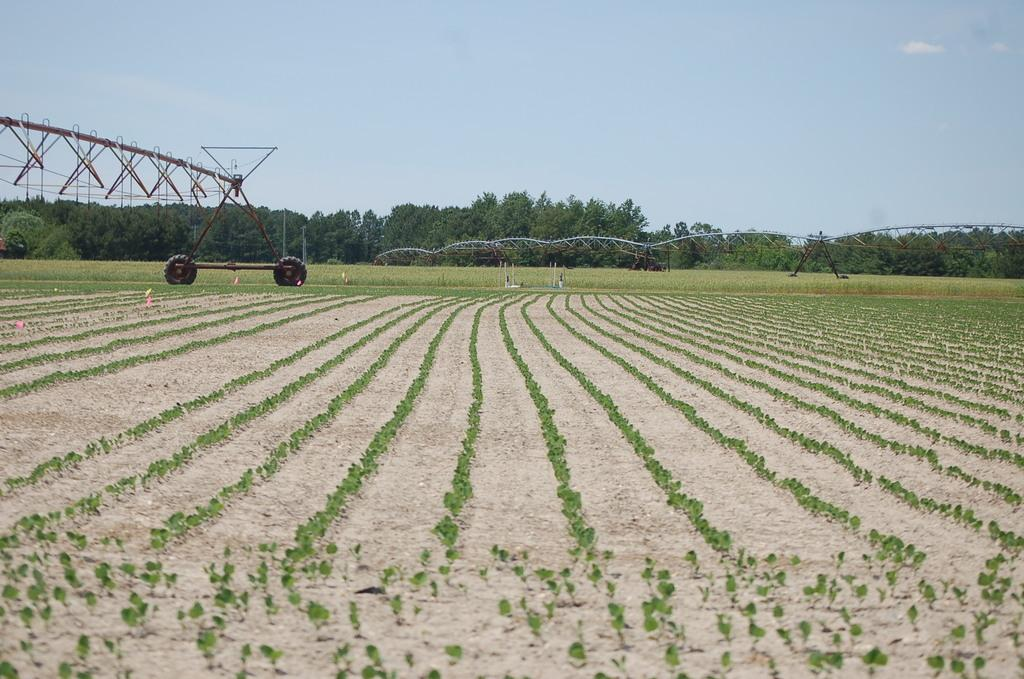What type of vegetation can be seen in the image? There are crops in the image. What structures are present among the crops? There are metal rod structures with tires in the image. What can be seen in the background of the image? There are trees in the background of the image. What is visible at the top of the image? The sky is visible at the top of the image. Can you tell me how many secretaries are working in the fields in the image? There are no secretaries present in the image; it features crops, metal rod structures, trees, and the sky. 